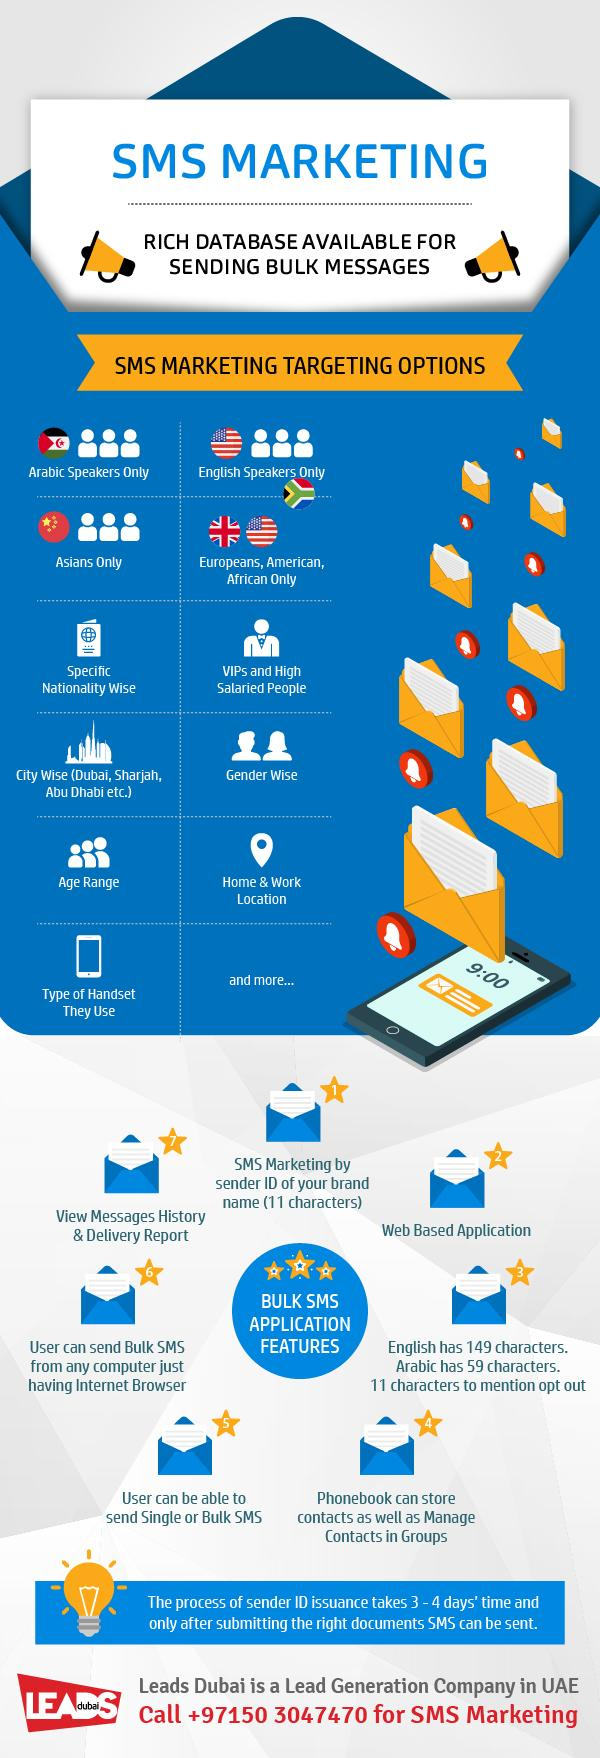Point out several critical features in this image. This infographic contains 7 bell icons. This infographic lists 11 targeting options for SMS marketing. The time mentioned on the phone is 9:00. There are two American flags depicted in this infographic. There are two public announcement systems featured in this infographic. 